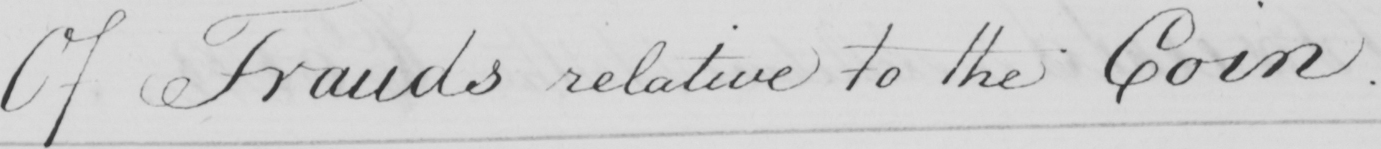Can you tell me what this handwritten text says? Of Frauds relative to the Coin . 